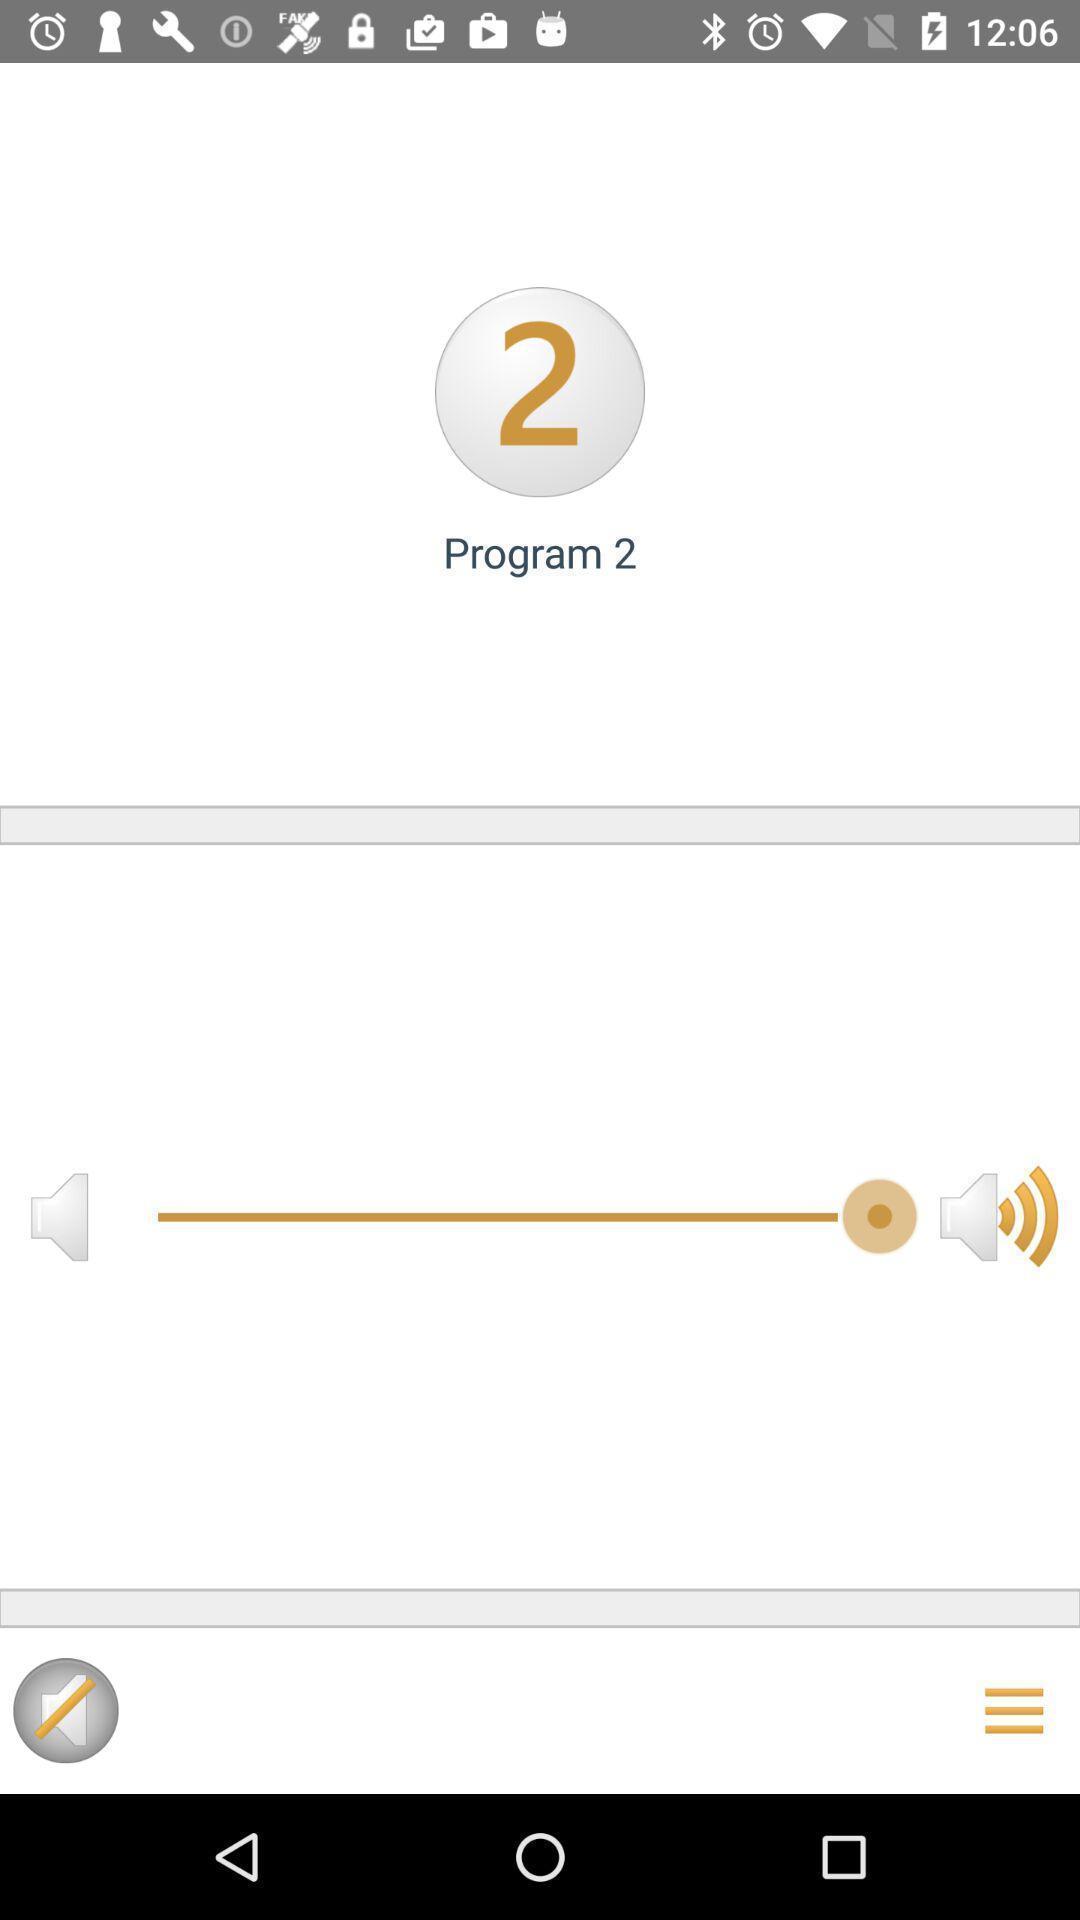Tell me what you see in this picture. Page displays volume level in app. 